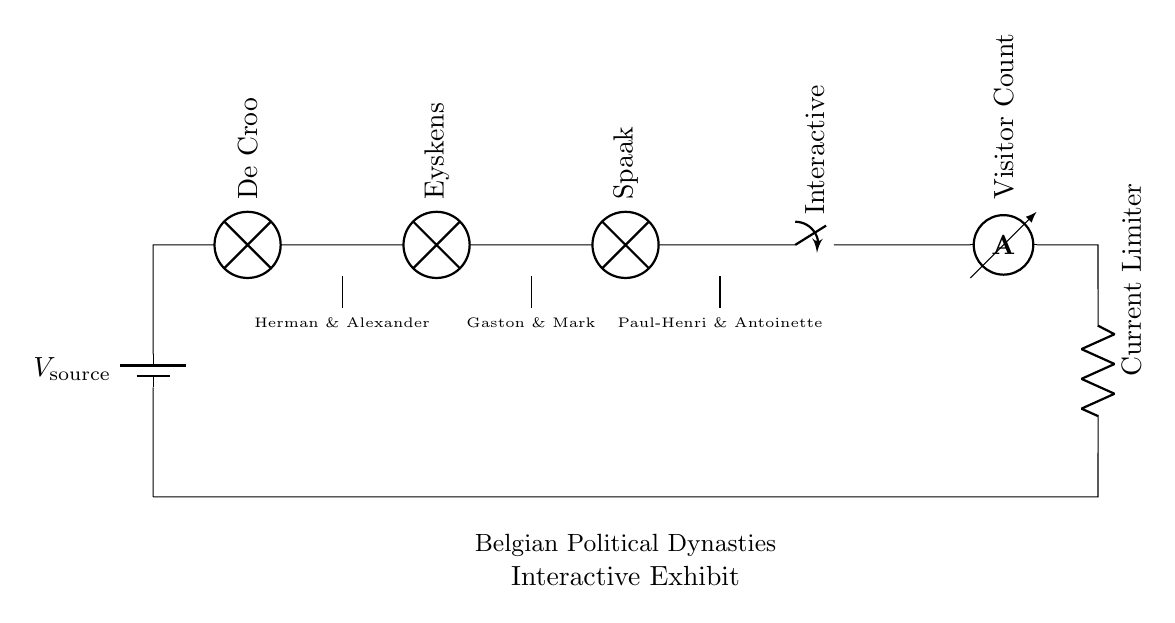What is the component labeled as De Croo? De Croo is represented as a lamp in the circuit diagram, indicating a lighting element associated with the political figure.
Answer: lamp How many lamps are present in the circuit? The circuit diagram shows three lamps, each labeled with a different political figure representing a dynasty in Belgium.
Answer: three What does the switch in the circuit signify? The switch allows for interaction, indicating that visitors can control the circuit to possibly turn on or off the lights associated with the political figures.
Answer: Interactive Which component limits the current in this circuit? The current limiter is indicated as a resistor in the circuit and is placed last in the sequence, preventing excess current through the lamps.
Answer: Current Limiter What do the labels under the lamps represent? The labels under the lamps indicate the names of notable Belgian politicians, denoting the legacies of political dynasties in the exhibit.
Answer: names of politicians What is the purpose of the ammeter in the circuit? The ammeter is used to measure the visitor count, suggesting that it tracks how many people interact with the exhibit and possibly engage with the lighting elements.
Answer: Visitor Count How does the circuit type influence the lighting display? Since this is a series circuit, the current flows through each lamp sequentially, meaning if one lamp fails to light up, the entire series circuit will not function.
Answer: series 